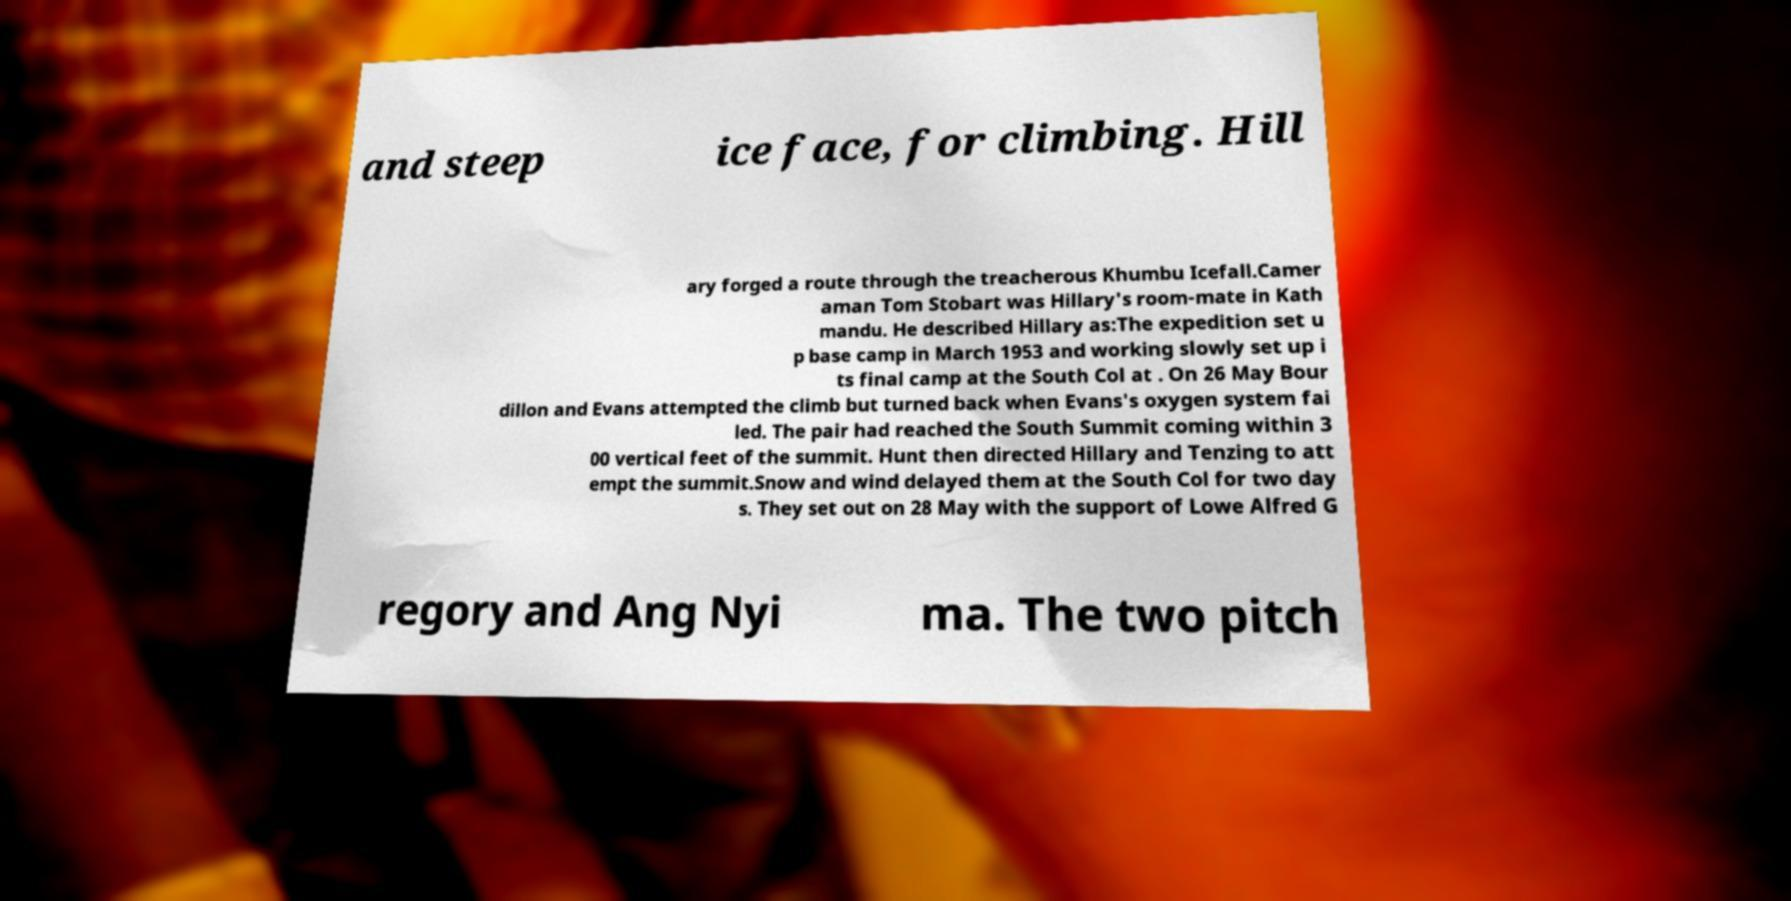Please read and relay the text visible in this image. What does it say? and steep ice face, for climbing. Hill ary forged a route through the treacherous Khumbu Icefall.Camer aman Tom Stobart was Hillary's room-mate in Kath mandu. He described Hillary as:The expedition set u p base camp in March 1953 and working slowly set up i ts final camp at the South Col at . On 26 May Bour dillon and Evans attempted the climb but turned back when Evans's oxygen system fai led. The pair had reached the South Summit coming within 3 00 vertical feet of the summit. Hunt then directed Hillary and Tenzing to att empt the summit.Snow and wind delayed them at the South Col for two day s. They set out on 28 May with the support of Lowe Alfred G regory and Ang Nyi ma. The two pitch 